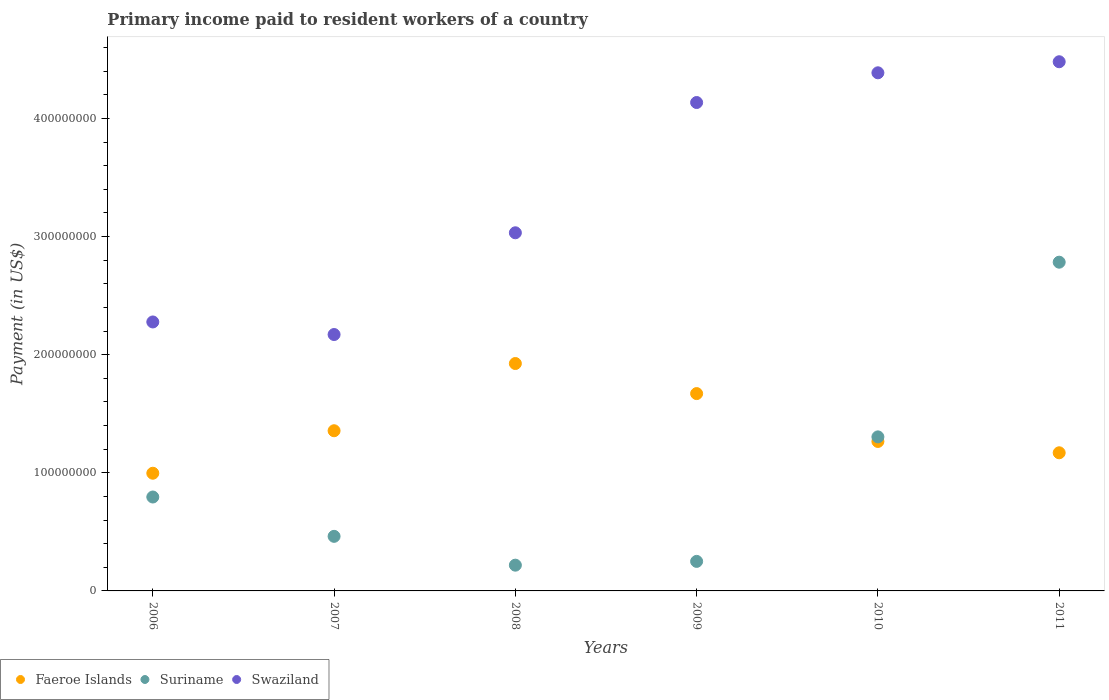Is the number of dotlines equal to the number of legend labels?
Give a very brief answer. Yes. What is the amount paid to workers in Swaziland in 2006?
Offer a very short reply. 2.28e+08. Across all years, what is the maximum amount paid to workers in Swaziland?
Provide a short and direct response. 4.48e+08. Across all years, what is the minimum amount paid to workers in Faeroe Islands?
Give a very brief answer. 9.96e+07. In which year was the amount paid to workers in Swaziland maximum?
Provide a succinct answer. 2011. In which year was the amount paid to workers in Swaziland minimum?
Keep it short and to the point. 2007. What is the total amount paid to workers in Faeroe Islands in the graph?
Ensure brevity in your answer.  8.38e+08. What is the difference between the amount paid to workers in Swaziland in 2010 and that in 2011?
Your answer should be very brief. -9.36e+06. What is the difference between the amount paid to workers in Swaziland in 2010 and the amount paid to workers in Faeroe Islands in 2007?
Your response must be concise. 3.03e+08. What is the average amount paid to workers in Faeroe Islands per year?
Make the answer very short. 1.40e+08. In the year 2008, what is the difference between the amount paid to workers in Swaziland and amount paid to workers in Faeroe Islands?
Your answer should be very brief. 1.11e+08. In how many years, is the amount paid to workers in Faeroe Islands greater than 240000000 US$?
Offer a very short reply. 0. What is the ratio of the amount paid to workers in Swaziland in 2007 to that in 2011?
Offer a terse response. 0.48. Is the amount paid to workers in Swaziland in 2006 less than that in 2010?
Provide a short and direct response. Yes. What is the difference between the highest and the second highest amount paid to workers in Faeroe Islands?
Provide a succinct answer. 2.55e+07. What is the difference between the highest and the lowest amount paid to workers in Swaziland?
Your answer should be compact. 2.31e+08. Does the amount paid to workers in Suriname monotonically increase over the years?
Offer a terse response. No. Is the amount paid to workers in Swaziland strictly greater than the amount paid to workers in Suriname over the years?
Make the answer very short. Yes. How many dotlines are there?
Give a very brief answer. 3. How many years are there in the graph?
Keep it short and to the point. 6. What is the difference between two consecutive major ticks on the Y-axis?
Your answer should be compact. 1.00e+08. Are the values on the major ticks of Y-axis written in scientific E-notation?
Offer a very short reply. No. Does the graph contain any zero values?
Ensure brevity in your answer.  No. Does the graph contain grids?
Offer a very short reply. No. How many legend labels are there?
Provide a succinct answer. 3. How are the legend labels stacked?
Offer a terse response. Horizontal. What is the title of the graph?
Provide a succinct answer. Primary income paid to resident workers of a country. What is the label or title of the X-axis?
Provide a short and direct response. Years. What is the label or title of the Y-axis?
Your answer should be compact. Payment (in US$). What is the Payment (in US$) in Faeroe Islands in 2006?
Ensure brevity in your answer.  9.96e+07. What is the Payment (in US$) of Suriname in 2006?
Your answer should be compact. 7.95e+07. What is the Payment (in US$) in Swaziland in 2006?
Offer a terse response. 2.28e+08. What is the Payment (in US$) in Faeroe Islands in 2007?
Your response must be concise. 1.36e+08. What is the Payment (in US$) in Suriname in 2007?
Offer a very short reply. 4.62e+07. What is the Payment (in US$) of Swaziland in 2007?
Provide a short and direct response. 2.17e+08. What is the Payment (in US$) in Faeroe Islands in 2008?
Make the answer very short. 1.92e+08. What is the Payment (in US$) of Suriname in 2008?
Provide a succinct answer. 2.18e+07. What is the Payment (in US$) of Swaziland in 2008?
Make the answer very short. 3.03e+08. What is the Payment (in US$) in Faeroe Islands in 2009?
Your answer should be very brief. 1.67e+08. What is the Payment (in US$) of Suriname in 2009?
Give a very brief answer. 2.50e+07. What is the Payment (in US$) of Swaziland in 2009?
Offer a very short reply. 4.13e+08. What is the Payment (in US$) in Faeroe Islands in 2010?
Ensure brevity in your answer.  1.27e+08. What is the Payment (in US$) in Suriname in 2010?
Provide a short and direct response. 1.30e+08. What is the Payment (in US$) of Swaziland in 2010?
Give a very brief answer. 4.39e+08. What is the Payment (in US$) of Faeroe Islands in 2011?
Ensure brevity in your answer.  1.17e+08. What is the Payment (in US$) of Suriname in 2011?
Offer a terse response. 2.78e+08. What is the Payment (in US$) of Swaziland in 2011?
Provide a succinct answer. 4.48e+08. Across all years, what is the maximum Payment (in US$) of Faeroe Islands?
Offer a terse response. 1.92e+08. Across all years, what is the maximum Payment (in US$) in Suriname?
Ensure brevity in your answer.  2.78e+08. Across all years, what is the maximum Payment (in US$) of Swaziland?
Provide a succinct answer. 4.48e+08. Across all years, what is the minimum Payment (in US$) of Faeroe Islands?
Your answer should be very brief. 9.96e+07. Across all years, what is the minimum Payment (in US$) of Suriname?
Keep it short and to the point. 2.18e+07. Across all years, what is the minimum Payment (in US$) of Swaziland?
Give a very brief answer. 2.17e+08. What is the total Payment (in US$) in Faeroe Islands in the graph?
Ensure brevity in your answer.  8.38e+08. What is the total Payment (in US$) of Suriname in the graph?
Your response must be concise. 5.81e+08. What is the total Payment (in US$) of Swaziland in the graph?
Your answer should be very brief. 2.05e+09. What is the difference between the Payment (in US$) of Faeroe Islands in 2006 and that in 2007?
Keep it short and to the point. -3.60e+07. What is the difference between the Payment (in US$) in Suriname in 2006 and that in 2007?
Your response must be concise. 3.33e+07. What is the difference between the Payment (in US$) in Swaziland in 2006 and that in 2007?
Your answer should be compact. 1.06e+07. What is the difference between the Payment (in US$) of Faeroe Islands in 2006 and that in 2008?
Ensure brevity in your answer.  -9.29e+07. What is the difference between the Payment (in US$) of Suriname in 2006 and that in 2008?
Make the answer very short. 5.77e+07. What is the difference between the Payment (in US$) of Swaziland in 2006 and that in 2008?
Offer a terse response. -7.55e+07. What is the difference between the Payment (in US$) in Faeroe Islands in 2006 and that in 2009?
Give a very brief answer. -6.74e+07. What is the difference between the Payment (in US$) in Suriname in 2006 and that in 2009?
Make the answer very short. 5.45e+07. What is the difference between the Payment (in US$) of Swaziland in 2006 and that in 2009?
Give a very brief answer. -1.86e+08. What is the difference between the Payment (in US$) in Faeroe Islands in 2006 and that in 2010?
Offer a terse response. -2.69e+07. What is the difference between the Payment (in US$) of Suriname in 2006 and that in 2010?
Give a very brief answer. -5.09e+07. What is the difference between the Payment (in US$) of Swaziland in 2006 and that in 2010?
Your answer should be very brief. -2.11e+08. What is the difference between the Payment (in US$) in Faeroe Islands in 2006 and that in 2011?
Provide a short and direct response. -1.73e+07. What is the difference between the Payment (in US$) of Suriname in 2006 and that in 2011?
Your answer should be very brief. -1.99e+08. What is the difference between the Payment (in US$) of Swaziland in 2006 and that in 2011?
Keep it short and to the point. -2.20e+08. What is the difference between the Payment (in US$) in Faeroe Islands in 2007 and that in 2008?
Your answer should be very brief. -5.69e+07. What is the difference between the Payment (in US$) in Suriname in 2007 and that in 2008?
Your answer should be compact. 2.44e+07. What is the difference between the Payment (in US$) in Swaziland in 2007 and that in 2008?
Ensure brevity in your answer.  -8.61e+07. What is the difference between the Payment (in US$) of Faeroe Islands in 2007 and that in 2009?
Offer a very short reply. -3.14e+07. What is the difference between the Payment (in US$) of Suriname in 2007 and that in 2009?
Provide a succinct answer. 2.12e+07. What is the difference between the Payment (in US$) of Swaziland in 2007 and that in 2009?
Make the answer very short. -1.96e+08. What is the difference between the Payment (in US$) of Faeroe Islands in 2007 and that in 2010?
Give a very brief answer. 9.08e+06. What is the difference between the Payment (in US$) of Suriname in 2007 and that in 2010?
Offer a very short reply. -8.42e+07. What is the difference between the Payment (in US$) of Swaziland in 2007 and that in 2010?
Make the answer very short. -2.22e+08. What is the difference between the Payment (in US$) in Faeroe Islands in 2007 and that in 2011?
Your answer should be very brief. 1.87e+07. What is the difference between the Payment (in US$) in Suriname in 2007 and that in 2011?
Your response must be concise. -2.32e+08. What is the difference between the Payment (in US$) in Swaziland in 2007 and that in 2011?
Give a very brief answer. -2.31e+08. What is the difference between the Payment (in US$) of Faeroe Islands in 2008 and that in 2009?
Your response must be concise. 2.55e+07. What is the difference between the Payment (in US$) in Suriname in 2008 and that in 2009?
Ensure brevity in your answer.  -3.20e+06. What is the difference between the Payment (in US$) in Swaziland in 2008 and that in 2009?
Ensure brevity in your answer.  -1.10e+08. What is the difference between the Payment (in US$) of Faeroe Islands in 2008 and that in 2010?
Your answer should be compact. 6.60e+07. What is the difference between the Payment (in US$) of Suriname in 2008 and that in 2010?
Your answer should be compact. -1.09e+08. What is the difference between the Payment (in US$) of Swaziland in 2008 and that in 2010?
Provide a short and direct response. -1.35e+08. What is the difference between the Payment (in US$) of Faeroe Islands in 2008 and that in 2011?
Your answer should be very brief. 7.56e+07. What is the difference between the Payment (in US$) in Suriname in 2008 and that in 2011?
Keep it short and to the point. -2.56e+08. What is the difference between the Payment (in US$) in Swaziland in 2008 and that in 2011?
Ensure brevity in your answer.  -1.45e+08. What is the difference between the Payment (in US$) of Faeroe Islands in 2009 and that in 2010?
Your answer should be very brief. 4.05e+07. What is the difference between the Payment (in US$) of Suriname in 2009 and that in 2010?
Give a very brief answer. -1.05e+08. What is the difference between the Payment (in US$) of Swaziland in 2009 and that in 2010?
Provide a succinct answer. -2.52e+07. What is the difference between the Payment (in US$) in Faeroe Islands in 2009 and that in 2011?
Your response must be concise. 5.01e+07. What is the difference between the Payment (in US$) of Suriname in 2009 and that in 2011?
Give a very brief answer. -2.53e+08. What is the difference between the Payment (in US$) in Swaziland in 2009 and that in 2011?
Offer a terse response. -3.45e+07. What is the difference between the Payment (in US$) of Faeroe Islands in 2010 and that in 2011?
Offer a very short reply. 9.58e+06. What is the difference between the Payment (in US$) of Suriname in 2010 and that in 2011?
Offer a very short reply. -1.48e+08. What is the difference between the Payment (in US$) in Swaziland in 2010 and that in 2011?
Your response must be concise. -9.36e+06. What is the difference between the Payment (in US$) in Faeroe Islands in 2006 and the Payment (in US$) in Suriname in 2007?
Your answer should be very brief. 5.34e+07. What is the difference between the Payment (in US$) of Faeroe Islands in 2006 and the Payment (in US$) of Swaziland in 2007?
Your response must be concise. -1.17e+08. What is the difference between the Payment (in US$) of Suriname in 2006 and the Payment (in US$) of Swaziland in 2007?
Your answer should be very brief. -1.38e+08. What is the difference between the Payment (in US$) of Faeroe Islands in 2006 and the Payment (in US$) of Suriname in 2008?
Your response must be concise. 7.78e+07. What is the difference between the Payment (in US$) of Faeroe Islands in 2006 and the Payment (in US$) of Swaziland in 2008?
Your answer should be very brief. -2.04e+08. What is the difference between the Payment (in US$) in Suriname in 2006 and the Payment (in US$) in Swaziland in 2008?
Your answer should be very brief. -2.24e+08. What is the difference between the Payment (in US$) in Faeroe Islands in 2006 and the Payment (in US$) in Suriname in 2009?
Make the answer very short. 7.46e+07. What is the difference between the Payment (in US$) in Faeroe Islands in 2006 and the Payment (in US$) in Swaziland in 2009?
Your answer should be compact. -3.14e+08. What is the difference between the Payment (in US$) in Suriname in 2006 and the Payment (in US$) in Swaziland in 2009?
Offer a terse response. -3.34e+08. What is the difference between the Payment (in US$) of Faeroe Islands in 2006 and the Payment (in US$) of Suriname in 2010?
Give a very brief answer. -3.08e+07. What is the difference between the Payment (in US$) of Faeroe Islands in 2006 and the Payment (in US$) of Swaziland in 2010?
Your answer should be very brief. -3.39e+08. What is the difference between the Payment (in US$) in Suriname in 2006 and the Payment (in US$) in Swaziland in 2010?
Your response must be concise. -3.59e+08. What is the difference between the Payment (in US$) of Faeroe Islands in 2006 and the Payment (in US$) of Suriname in 2011?
Offer a very short reply. -1.79e+08. What is the difference between the Payment (in US$) in Faeroe Islands in 2006 and the Payment (in US$) in Swaziland in 2011?
Give a very brief answer. -3.48e+08. What is the difference between the Payment (in US$) in Suriname in 2006 and the Payment (in US$) in Swaziland in 2011?
Ensure brevity in your answer.  -3.68e+08. What is the difference between the Payment (in US$) of Faeroe Islands in 2007 and the Payment (in US$) of Suriname in 2008?
Provide a short and direct response. 1.14e+08. What is the difference between the Payment (in US$) in Faeroe Islands in 2007 and the Payment (in US$) in Swaziland in 2008?
Your response must be concise. -1.68e+08. What is the difference between the Payment (in US$) in Suriname in 2007 and the Payment (in US$) in Swaziland in 2008?
Ensure brevity in your answer.  -2.57e+08. What is the difference between the Payment (in US$) of Faeroe Islands in 2007 and the Payment (in US$) of Suriname in 2009?
Offer a terse response. 1.11e+08. What is the difference between the Payment (in US$) of Faeroe Islands in 2007 and the Payment (in US$) of Swaziland in 2009?
Your answer should be compact. -2.78e+08. What is the difference between the Payment (in US$) in Suriname in 2007 and the Payment (in US$) in Swaziland in 2009?
Give a very brief answer. -3.67e+08. What is the difference between the Payment (in US$) of Faeroe Islands in 2007 and the Payment (in US$) of Suriname in 2010?
Your answer should be compact. 5.20e+06. What is the difference between the Payment (in US$) of Faeroe Islands in 2007 and the Payment (in US$) of Swaziland in 2010?
Ensure brevity in your answer.  -3.03e+08. What is the difference between the Payment (in US$) of Suriname in 2007 and the Payment (in US$) of Swaziland in 2010?
Make the answer very short. -3.92e+08. What is the difference between the Payment (in US$) in Faeroe Islands in 2007 and the Payment (in US$) in Suriname in 2011?
Make the answer very short. -1.43e+08. What is the difference between the Payment (in US$) in Faeroe Islands in 2007 and the Payment (in US$) in Swaziland in 2011?
Offer a terse response. -3.12e+08. What is the difference between the Payment (in US$) in Suriname in 2007 and the Payment (in US$) in Swaziland in 2011?
Offer a terse response. -4.02e+08. What is the difference between the Payment (in US$) in Faeroe Islands in 2008 and the Payment (in US$) in Suriname in 2009?
Your response must be concise. 1.67e+08. What is the difference between the Payment (in US$) in Faeroe Islands in 2008 and the Payment (in US$) in Swaziland in 2009?
Keep it short and to the point. -2.21e+08. What is the difference between the Payment (in US$) in Suriname in 2008 and the Payment (in US$) in Swaziland in 2009?
Provide a succinct answer. -3.92e+08. What is the difference between the Payment (in US$) in Faeroe Islands in 2008 and the Payment (in US$) in Suriname in 2010?
Provide a succinct answer. 6.21e+07. What is the difference between the Payment (in US$) of Faeroe Islands in 2008 and the Payment (in US$) of Swaziland in 2010?
Ensure brevity in your answer.  -2.46e+08. What is the difference between the Payment (in US$) of Suriname in 2008 and the Payment (in US$) of Swaziland in 2010?
Give a very brief answer. -4.17e+08. What is the difference between the Payment (in US$) of Faeroe Islands in 2008 and the Payment (in US$) of Suriname in 2011?
Your response must be concise. -8.58e+07. What is the difference between the Payment (in US$) of Faeroe Islands in 2008 and the Payment (in US$) of Swaziland in 2011?
Offer a terse response. -2.55e+08. What is the difference between the Payment (in US$) in Suriname in 2008 and the Payment (in US$) in Swaziland in 2011?
Offer a terse response. -4.26e+08. What is the difference between the Payment (in US$) of Faeroe Islands in 2009 and the Payment (in US$) of Suriname in 2010?
Your answer should be very brief. 3.66e+07. What is the difference between the Payment (in US$) of Faeroe Islands in 2009 and the Payment (in US$) of Swaziland in 2010?
Give a very brief answer. -2.72e+08. What is the difference between the Payment (in US$) in Suriname in 2009 and the Payment (in US$) in Swaziland in 2010?
Ensure brevity in your answer.  -4.14e+08. What is the difference between the Payment (in US$) in Faeroe Islands in 2009 and the Payment (in US$) in Suriname in 2011?
Offer a very short reply. -1.11e+08. What is the difference between the Payment (in US$) of Faeroe Islands in 2009 and the Payment (in US$) of Swaziland in 2011?
Ensure brevity in your answer.  -2.81e+08. What is the difference between the Payment (in US$) of Suriname in 2009 and the Payment (in US$) of Swaziland in 2011?
Your answer should be very brief. -4.23e+08. What is the difference between the Payment (in US$) in Faeroe Islands in 2010 and the Payment (in US$) in Suriname in 2011?
Your response must be concise. -1.52e+08. What is the difference between the Payment (in US$) of Faeroe Islands in 2010 and the Payment (in US$) of Swaziland in 2011?
Provide a succinct answer. -3.21e+08. What is the difference between the Payment (in US$) in Suriname in 2010 and the Payment (in US$) in Swaziland in 2011?
Your answer should be very brief. -3.18e+08. What is the average Payment (in US$) of Faeroe Islands per year?
Your answer should be compact. 1.40e+08. What is the average Payment (in US$) in Suriname per year?
Offer a terse response. 9.69e+07. What is the average Payment (in US$) in Swaziland per year?
Keep it short and to the point. 3.41e+08. In the year 2006, what is the difference between the Payment (in US$) in Faeroe Islands and Payment (in US$) in Suriname?
Make the answer very short. 2.01e+07. In the year 2006, what is the difference between the Payment (in US$) of Faeroe Islands and Payment (in US$) of Swaziland?
Offer a very short reply. -1.28e+08. In the year 2006, what is the difference between the Payment (in US$) in Suriname and Payment (in US$) in Swaziland?
Your answer should be very brief. -1.48e+08. In the year 2007, what is the difference between the Payment (in US$) in Faeroe Islands and Payment (in US$) in Suriname?
Your answer should be compact. 8.94e+07. In the year 2007, what is the difference between the Payment (in US$) in Faeroe Islands and Payment (in US$) in Swaziland?
Ensure brevity in your answer.  -8.14e+07. In the year 2007, what is the difference between the Payment (in US$) in Suriname and Payment (in US$) in Swaziland?
Ensure brevity in your answer.  -1.71e+08. In the year 2008, what is the difference between the Payment (in US$) in Faeroe Islands and Payment (in US$) in Suriname?
Your response must be concise. 1.71e+08. In the year 2008, what is the difference between the Payment (in US$) of Faeroe Islands and Payment (in US$) of Swaziland?
Offer a very short reply. -1.11e+08. In the year 2008, what is the difference between the Payment (in US$) in Suriname and Payment (in US$) in Swaziland?
Provide a succinct answer. -2.81e+08. In the year 2009, what is the difference between the Payment (in US$) in Faeroe Islands and Payment (in US$) in Suriname?
Provide a succinct answer. 1.42e+08. In the year 2009, what is the difference between the Payment (in US$) in Faeroe Islands and Payment (in US$) in Swaziland?
Your answer should be very brief. -2.46e+08. In the year 2009, what is the difference between the Payment (in US$) of Suriname and Payment (in US$) of Swaziland?
Offer a terse response. -3.88e+08. In the year 2010, what is the difference between the Payment (in US$) of Faeroe Islands and Payment (in US$) of Suriname?
Your response must be concise. -3.88e+06. In the year 2010, what is the difference between the Payment (in US$) of Faeroe Islands and Payment (in US$) of Swaziland?
Your answer should be very brief. -3.12e+08. In the year 2010, what is the difference between the Payment (in US$) in Suriname and Payment (in US$) in Swaziland?
Your response must be concise. -3.08e+08. In the year 2011, what is the difference between the Payment (in US$) in Faeroe Islands and Payment (in US$) in Suriname?
Make the answer very short. -1.61e+08. In the year 2011, what is the difference between the Payment (in US$) in Faeroe Islands and Payment (in US$) in Swaziland?
Your response must be concise. -3.31e+08. In the year 2011, what is the difference between the Payment (in US$) of Suriname and Payment (in US$) of Swaziland?
Your answer should be compact. -1.70e+08. What is the ratio of the Payment (in US$) of Faeroe Islands in 2006 to that in 2007?
Ensure brevity in your answer.  0.73. What is the ratio of the Payment (in US$) in Suriname in 2006 to that in 2007?
Your answer should be compact. 1.72. What is the ratio of the Payment (in US$) in Swaziland in 2006 to that in 2007?
Offer a very short reply. 1.05. What is the ratio of the Payment (in US$) of Faeroe Islands in 2006 to that in 2008?
Make the answer very short. 0.52. What is the ratio of the Payment (in US$) in Suriname in 2006 to that in 2008?
Give a very brief answer. 3.65. What is the ratio of the Payment (in US$) of Swaziland in 2006 to that in 2008?
Offer a very short reply. 0.75. What is the ratio of the Payment (in US$) in Faeroe Islands in 2006 to that in 2009?
Give a very brief answer. 0.6. What is the ratio of the Payment (in US$) in Suriname in 2006 to that in 2009?
Your response must be concise. 3.18. What is the ratio of the Payment (in US$) of Swaziland in 2006 to that in 2009?
Give a very brief answer. 0.55. What is the ratio of the Payment (in US$) in Faeroe Islands in 2006 to that in 2010?
Keep it short and to the point. 0.79. What is the ratio of the Payment (in US$) in Suriname in 2006 to that in 2010?
Give a very brief answer. 0.61. What is the ratio of the Payment (in US$) of Swaziland in 2006 to that in 2010?
Your response must be concise. 0.52. What is the ratio of the Payment (in US$) of Faeroe Islands in 2006 to that in 2011?
Offer a terse response. 0.85. What is the ratio of the Payment (in US$) in Suriname in 2006 to that in 2011?
Give a very brief answer. 0.29. What is the ratio of the Payment (in US$) in Swaziland in 2006 to that in 2011?
Offer a very short reply. 0.51. What is the ratio of the Payment (in US$) in Faeroe Islands in 2007 to that in 2008?
Offer a terse response. 0.7. What is the ratio of the Payment (in US$) in Suriname in 2007 to that in 2008?
Keep it short and to the point. 2.12. What is the ratio of the Payment (in US$) of Swaziland in 2007 to that in 2008?
Make the answer very short. 0.72. What is the ratio of the Payment (in US$) in Faeroe Islands in 2007 to that in 2009?
Give a very brief answer. 0.81. What is the ratio of the Payment (in US$) of Suriname in 2007 to that in 2009?
Offer a terse response. 1.85. What is the ratio of the Payment (in US$) of Swaziland in 2007 to that in 2009?
Keep it short and to the point. 0.53. What is the ratio of the Payment (in US$) in Faeroe Islands in 2007 to that in 2010?
Ensure brevity in your answer.  1.07. What is the ratio of the Payment (in US$) of Suriname in 2007 to that in 2010?
Offer a very short reply. 0.35. What is the ratio of the Payment (in US$) of Swaziland in 2007 to that in 2010?
Make the answer very short. 0.49. What is the ratio of the Payment (in US$) of Faeroe Islands in 2007 to that in 2011?
Provide a succinct answer. 1.16. What is the ratio of the Payment (in US$) in Suriname in 2007 to that in 2011?
Give a very brief answer. 0.17. What is the ratio of the Payment (in US$) in Swaziland in 2007 to that in 2011?
Your answer should be very brief. 0.48. What is the ratio of the Payment (in US$) in Faeroe Islands in 2008 to that in 2009?
Offer a terse response. 1.15. What is the ratio of the Payment (in US$) of Suriname in 2008 to that in 2009?
Offer a terse response. 0.87. What is the ratio of the Payment (in US$) of Swaziland in 2008 to that in 2009?
Keep it short and to the point. 0.73. What is the ratio of the Payment (in US$) of Faeroe Islands in 2008 to that in 2010?
Your answer should be compact. 1.52. What is the ratio of the Payment (in US$) in Suriname in 2008 to that in 2010?
Offer a very short reply. 0.17. What is the ratio of the Payment (in US$) in Swaziland in 2008 to that in 2010?
Keep it short and to the point. 0.69. What is the ratio of the Payment (in US$) in Faeroe Islands in 2008 to that in 2011?
Your answer should be very brief. 1.65. What is the ratio of the Payment (in US$) in Suriname in 2008 to that in 2011?
Keep it short and to the point. 0.08. What is the ratio of the Payment (in US$) of Swaziland in 2008 to that in 2011?
Give a very brief answer. 0.68. What is the ratio of the Payment (in US$) in Faeroe Islands in 2009 to that in 2010?
Your answer should be very brief. 1.32. What is the ratio of the Payment (in US$) of Suriname in 2009 to that in 2010?
Offer a very short reply. 0.19. What is the ratio of the Payment (in US$) in Swaziland in 2009 to that in 2010?
Your answer should be very brief. 0.94. What is the ratio of the Payment (in US$) of Faeroe Islands in 2009 to that in 2011?
Your answer should be very brief. 1.43. What is the ratio of the Payment (in US$) of Suriname in 2009 to that in 2011?
Provide a short and direct response. 0.09. What is the ratio of the Payment (in US$) in Swaziland in 2009 to that in 2011?
Provide a short and direct response. 0.92. What is the ratio of the Payment (in US$) of Faeroe Islands in 2010 to that in 2011?
Offer a terse response. 1.08. What is the ratio of the Payment (in US$) in Suriname in 2010 to that in 2011?
Keep it short and to the point. 0.47. What is the ratio of the Payment (in US$) of Swaziland in 2010 to that in 2011?
Your response must be concise. 0.98. What is the difference between the highest and the second highest Payment (in US$) of Faeroe Islands?
Ensure brevity in your answer.  2.55e+07. What is the difference between the highest and the second highest Payment (in US$) of Suriname?
Make the answer very short. 1.48e+08. What is the difference between the highest and the second highest Payment (in US$) in Swaziland?
Offer a terse response. 9.36e+06. What is the difference between the highest and the lowest Payment (in US$) in Faeroe Islands?
Give a very brief answer. 9.29e+07. What is the difference between the highest and the lowest Payment (in US$) in Suriname?
Offer a very short reply. 2.56e+08. What is the difference between the highest and the lowest Payment (in US$) of Swaziland?
Ensure brevity in your answer.  2.31e+08. 